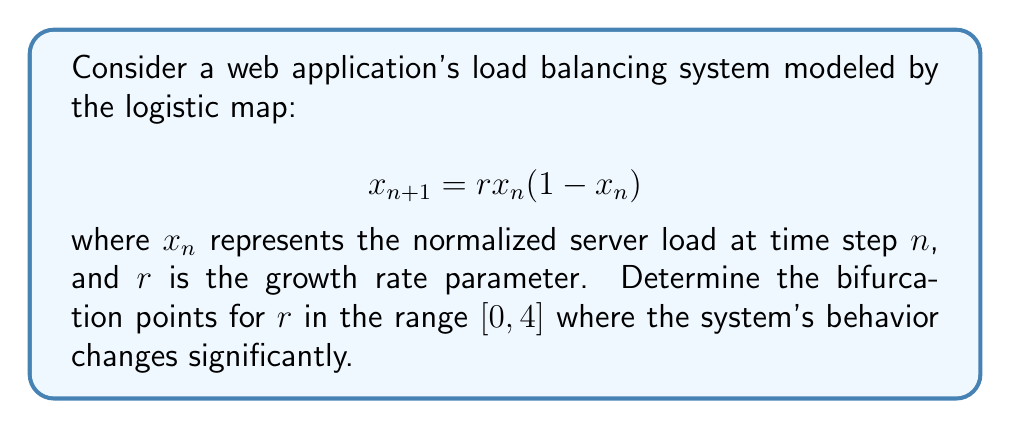Can you solve this math problem? To determine the bifurcation points, we need to analyze the stability of the fixed points and their period-doubling bifurcations:

1. Find the fixed points:
   Set $x_{n+1} = x_n = x^*$
   $$x^* = rx^*(1-x^*)$$
   Solving this equation yields two fixed points:
   $$x^*_1 = 0 \text{ and } x^*_2 = 1 - \frac{1}{r}$$

2. Analyze stability of $x^*_1 = 0$:
   The derivative of the map at $x^*_1$ is:
   $$f'(x^*_1) = r$$
   The fixed point is stable when $|f'(x^*_1)| < 1$, i.e., when $-1 < r < 1$
   The first bifurcation occurs at $r = 1$

3. Analyze stability of $x^*_2 = 1 - \frac{1}{r}$:
   The derivative of the map at $x^*_2$ is:
   $$f'(x^*_2) = 2 - r$$
   The fixed point is stable when $|f'(x^*_2)| < 1$, i.e., when $1 < r < 3$
   The second bifurcation occurs at $r = 3$

4. Period-doubling bifurcations:
   After $r = 3$, the system undergoes a series of period-doubling bifurcations.
   The next significant bifurcation points are:
   - Period-4 cycle at $r \approx 3.45$
   - Period-8 cycle at $r \approx 3.57$
   - Onset of chaos at $r \approx 3.57$

5. Final bifurcation:
   At $r = 4$, the system reaches its maximum chaotic behavior.

Therefore, the main bifurcation points are $r = 1$, $r = 3$, and $r = 4$, with additional period-doubling bifurcations occurring between $r = 3$ and $r = 4$.
Answer: $r = 1$, $r = 3$, $r = 4$ 